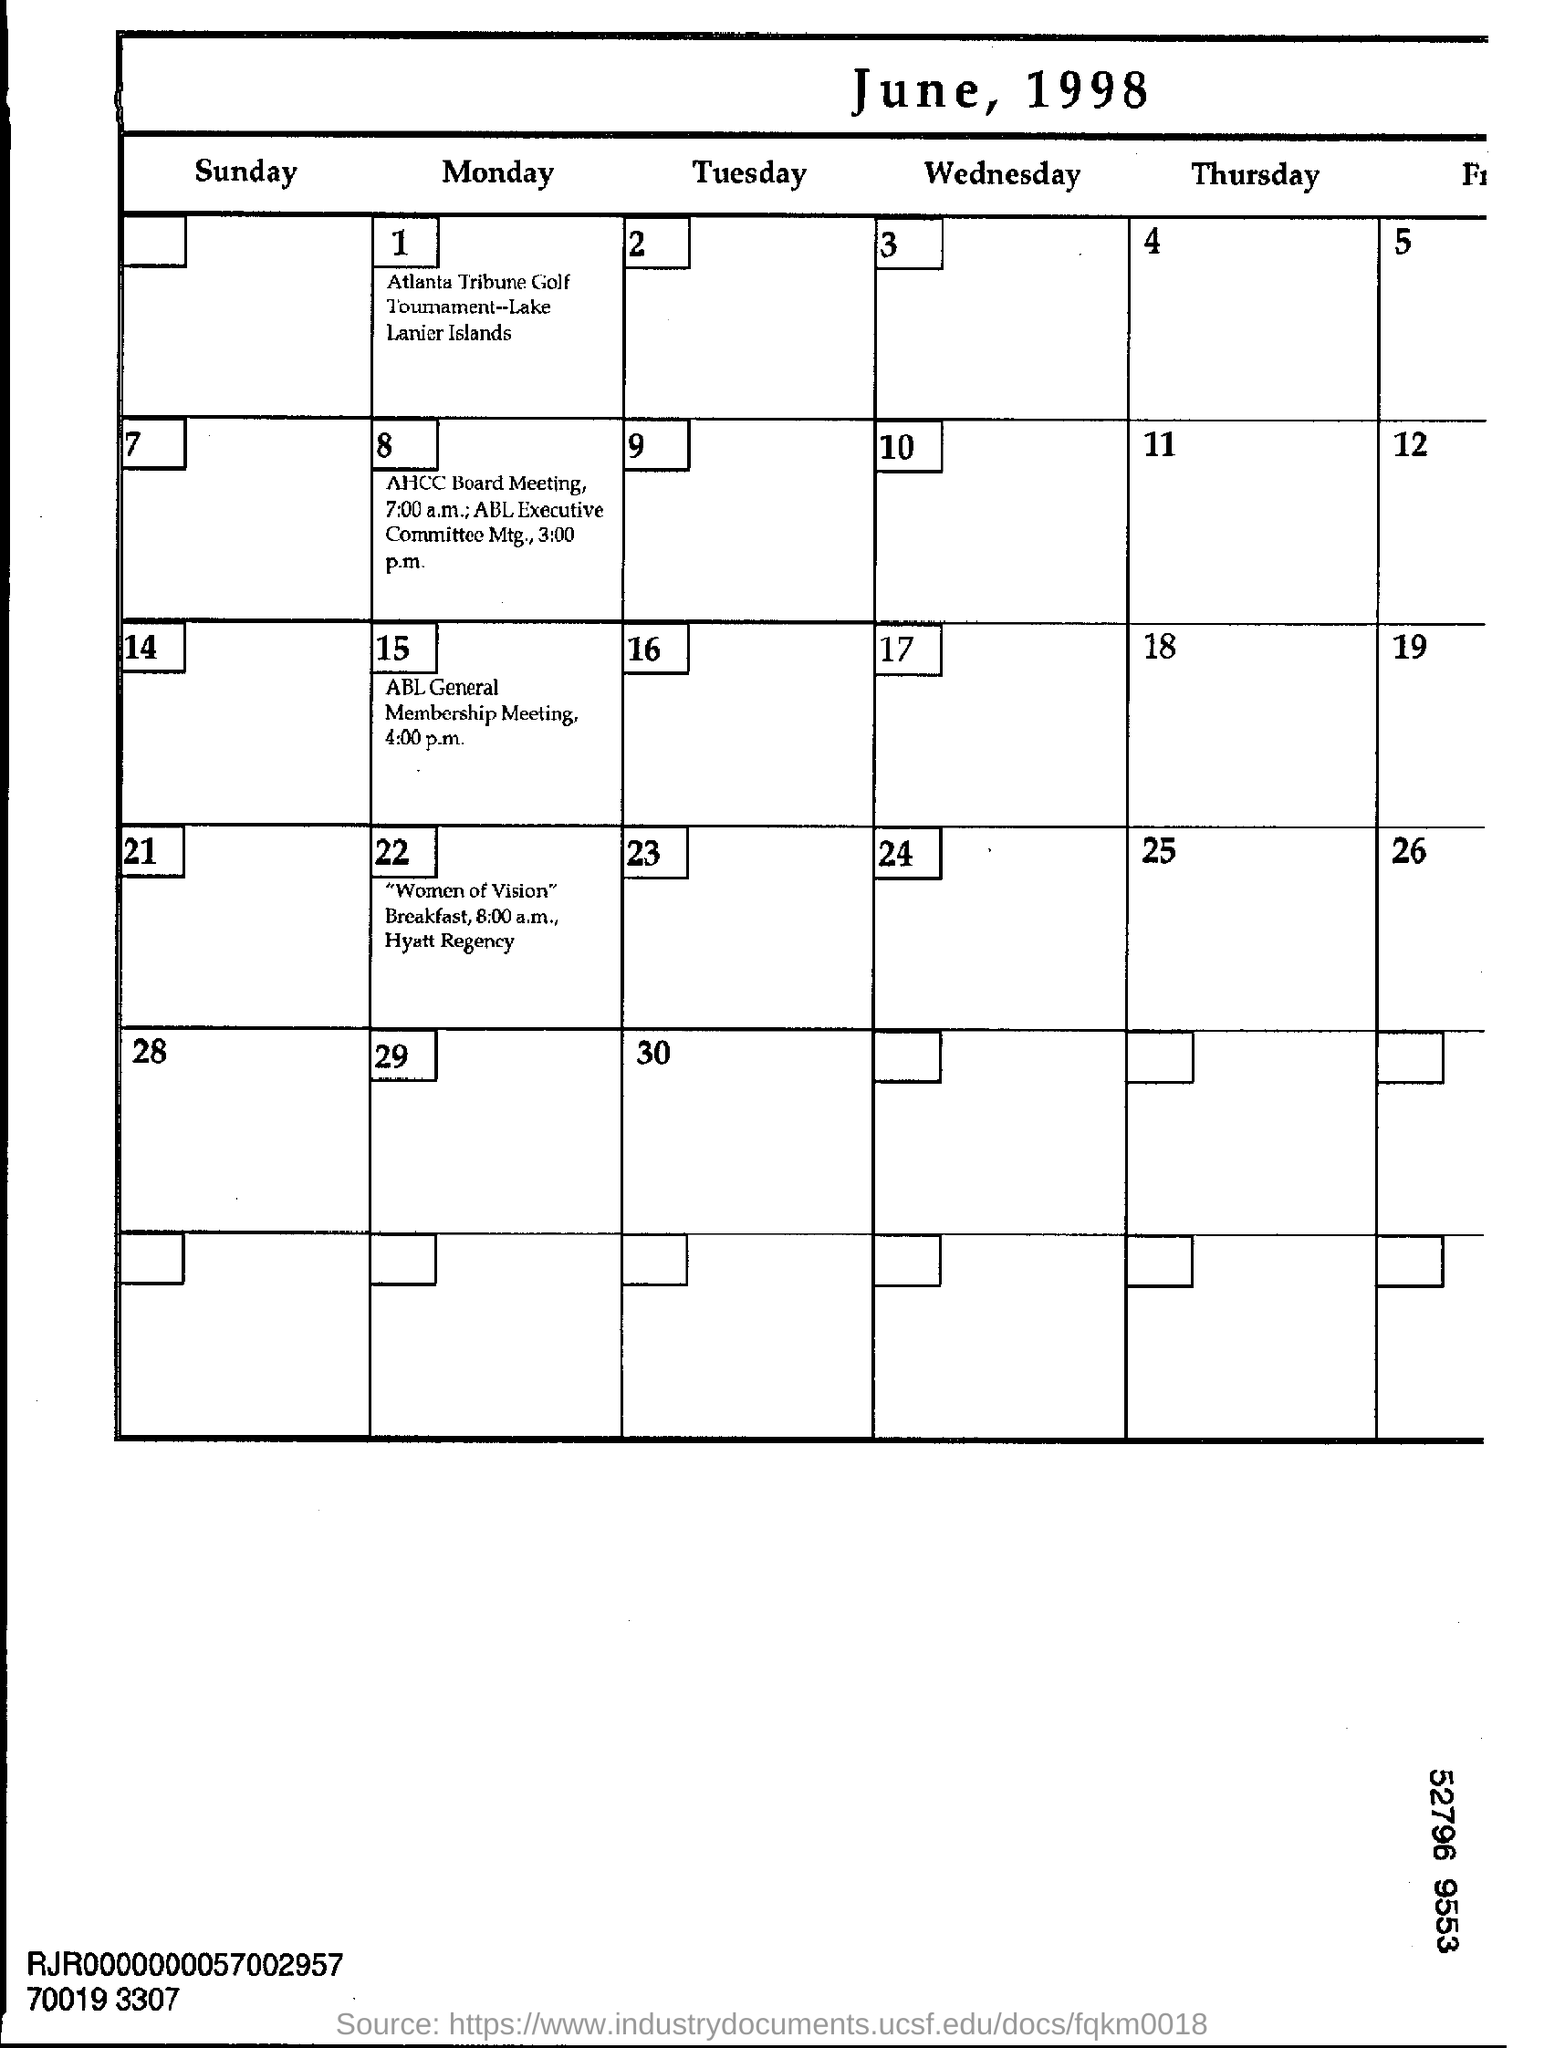When is Atlanta Tribune Golf Tournament ?
Make the answer very short. 1 June, 1998. Where is Atlanta Tribune Golf Tournament going to be held ?
Keep it short and to the point. Lake Lanier Islands. What time is ABL General Membership Meeting scheduled?
Offer a terse response. 4:00 p.m. At what time AHCC Board Meeting will start ?
Provide a short and direct response. 7;00 a.m. At what time ABL Executive Committee Mtg will start ?
Make the answer very short. 3:00 pm. 